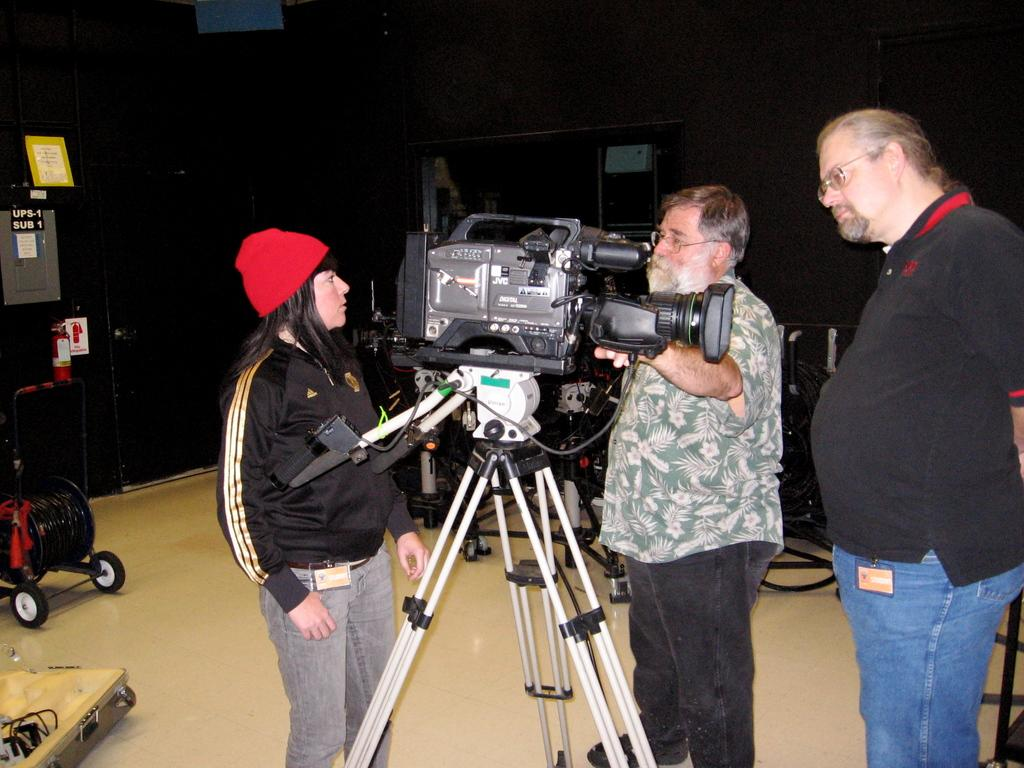How many people are in the image? There are three persons in the image. What equipment is present in the image? There is a camera on a tripod in the image. What type of objects can be seen near the camera? There are trolleys in the image. What do the boards with text indicate? The boards with text may provide information or instructions. What else can be seen in the image? There are wires visible in the image. What is the background of the image? There is a wall in the image. What type of debt is being discussed in the image? There is no mention of debt in the image; it features a camera, trolleys, boards with text, wires, and a wall. Can you see a beetle crawling on the wall in the image? No, there is no beetle visible in the image. Are any mittens present in the image? No, there are no mittens present in the image. 